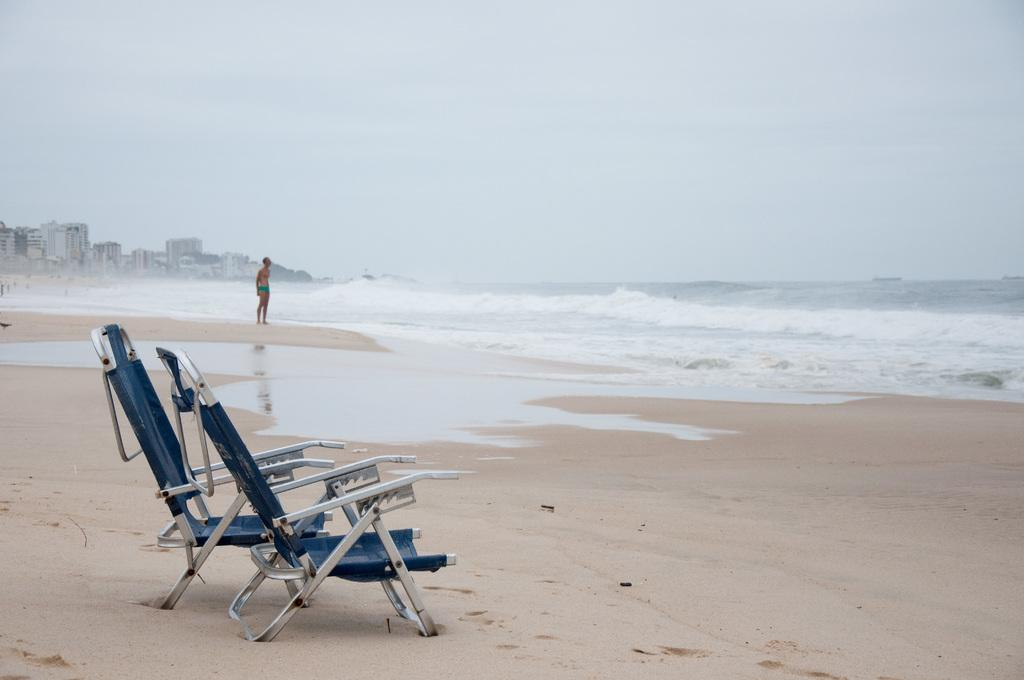What type of location is depicted in the image? There is a beach in the image. What furniture can be seen on the beach? There are two chairs on the beach. Are there any people present on the beach? Yes, there is a person on the beach. What can be seen in the background of the image? There are buildings visible near the beach. What type of curve can be seen on the secretary's desk in the image? There is no secretary or desk present in the image; it features a beach with chairs and a person. 